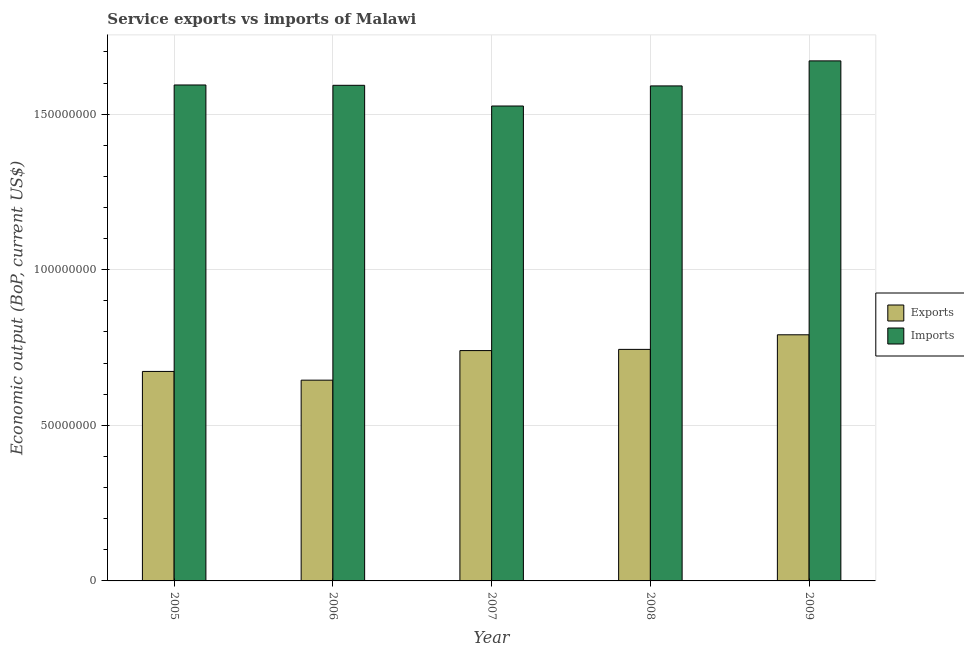How many groups of bars are there?
Your answer should be compact. 5. Are the number of bars per tick equal to the number of legend labels?
Provide a succinct answer. Yes. Are the number of bars on each tick of the X-axis equal?
Offer a terse response. Yes. How many bars are there on the 1st tick from the left?
Make the answer very short. 2. In how many cases, is the number of bars for a given year not equal to the number of legend labels?
Your response must be concise. 0. What is the amount of service imports in 2007?
Keep it short and to the point. 1.53e+08. Across all years, what is the maximum amount of service exports?
Your answer should be compact. 7.91e+07. Across all years, what is the minimum amount of service exports?
Your response must be concise. 6.45e+07. In which year was the amount of service imports minimum?
Offer a terse response. 2007. What is the total amount of service exports in the graph?
Your response must be concise. 3.59e+08. What is the difference between the amount of service exports in 2006 and that in 2009?
Your answer should be very brief. -1.46e+07. What is the difference between the amount of service imports in 2005 and the amount of service exports in 2009?
Ensure brevity in your answer.  -7.74e+06. What is the average amount of service imports per year?
Provide a succinct answer. 1.59e+08. In the year 2006, what is the difference between the amount of service exports and amount of service imports?
Give a very brief answer. 0. In how many years, is the amount of service exports greater than 90000000 US$?
Make the answer very short. 0. What is the ratio of the amount of service exports in 2005 to that in 2009?
Ensure brevity in your answer.  0.85. Is the amount of service imports in 2007 less than that in 2008?
Offer a very short reply. Yes. What is the difference between the highest and the second highest amount of service exports?
Ensure brevity in your answer.  4.69e+06. What is the difference between the highest and the lowest amount of service exports?
Offer a very short reply. 1.46e+07. Is the sum of the amount of service exports in 2005 and 2007 greater than the maximum amount of service imports across all years?
Offer a terse response. Yes. What does the 1st bar from the left in 2006 represents?
Make the answer very short. Exports. What does the 1st bar from the right in 2008 represents?
Give a very brief answer. Imports. How many years are there in the graph?
Provide a short and direct response. 5. Does the graph contain any zero values?
Keep it short and to the point. No. Where does the legend appear in the graph?
Your answer should be very brief. Center right. How many legend labels are there?
Offer a very short reply. 2. How are the legend labels stacked?
Give a very brief answer. Vertical. What is the title of the graph?
Keep it short and to the point. Service exports vs imports of Malawi. Does "From World Bank" appear as one of the legend labels in the graph?
Your answer should be very brief. No. What is the label or title of the Y-axis?
Give a very brief answer. Economic output (BoP, current US$). What is the Economic output (BoP, current US$) of Exports in 2005?
Your response must be concise. 6.73e+07. What is the Economic output (BoP, current US$) in Imports in 2005?
Your response must be concise. 1.59e+08. What is the Economic output (BoP, current US$) of Exports in 2006?
Offer a terse response. 6.45e+07. What is the Economic output (BoP, current US$) of Imports in 2006?
Give a very brief answer. 1.59e+08. What is the Economic output (BoP, current US$) in Exports in 2007?
Give a very brief answer. 7.40e+07. What is the Economic output (BoP, current US$) in Imports in 2007?
Offer a very short reply. 1.53e+08. What is the Economic output (BoP, current US$) in Exports in 2008?
Ensure brevity in your answer.  7.44e+07. What is the Economic output (BoP, current US$) of Imports in 2008?
Your response must be concise. 1.59e+08. What is the Economic output (BoP, current US$) in Exports in 2009?
Offer a very short reply. 7.91e+07. What is the Economic output (BoP, current US$) of Imports in 2009?
Your answer should be compact. 1.67e+08. Across all years, what is the maximum Economic output (BoP, current US$) in Exports?
Make the answer very short. 7.91e+07. Across all years, what is the maximum Economic output (BoP, current US$) in Imports?
Make the answer very short. 1.67e+08. Across all years, what is the minimum Economic output (BoP, current US$) in Exports?
Keep it short and to the point. 6.45e+07. Across all years, what is the minimum Economic output (BoP, current US$) in Imports?
Your response must be concise. 1.53e+08. What is the total Economic output (BoP, current US$) of Exports in the graph?
Your answer should be very brief. 3.59e+08. What is the total Economic output (BoP, current US$) of Imports in the graph?
Offer a terse response. 7.97e+08. What is the difference between the Economic output (BoP, current US$) in Exports in 2005 and that in 2006?
Provide a succinct answer. 2.81e+06. What is the difference between the Economic output (BoP, current US$) of Imports in 2005 and that in 2006?
Your answer should be very brief. 1.06e+05. What is the difference between the Economic output (BoP, current US$) in Exports in 2005 and that in 2007?
Provide a succinct answer. -6.69e+06. What is the difference between the Economic output (BoP, current US$) in Imports in 2005 and that in 2007?
Provide a succinct answer. 6.76e+06. What is the difference between the Economic output (BoP, current US$) of Exports in 2005 and that in 2008?
Your answer should be compact. -7.08e+06. What is the difference between the Economic output (BoP, current US$) in Imports in 2005 and that in 2008?
Offer a terse response. 3.03e+05. What is the difference between the Economic output (BoP, current US$) of Exports in 2005 and that in 2009?
Keep it short and to the point. -1.18e+07. What is the difference between the Economic output (BoP, current US$) of Imports in 2005 and that in 2009?
Offer a very short reply. -7.74e+06. What is the difference between the Economic output (BoP, current US$) of Exports in 2006 and that in 2007?
Provide a succinct answer. -9.50e+06. What is the difference between the Economic output (BoP, current US$) of Imports in 2006 and that in 2007?
Make the answer very short. 6.65e+06. What is the difference between the Economic output (BoP, current US$) of Exports in 2006 and that in 2008?
Ensure brevity in your answer.  -9.89e+06. What is the difference between the Economic output (BoP, current US$) of Imports in 2006 and that in 2008?
Offer a very short reply. 1.97e+05. What is the difference between the Economic output (BoP, current US$) in Exports in 2006 and that in 2009?
Give a very brief answer. -1.46e+07. What is the difference between the Economic output (BoP, current US$) of Imports in 2006 and that in 2009?
Provide a succinct answer. -7.85e+06. What is the difference between the Economic output (BoP, current US$) in Exports in 2007 and that in 2008?
Keep it short and to the point. -3.88e+05. What is the difference between the Economic output (BoP, current US$) in Imports in 2007 and that in 2008?
Your answer should be compact. -6.45e+06. What is the difference between the Economic output (BoP, current US$) in Exports in 2007 and that in 2009?
Provide a short and direct response. -5.08e+06. What is the difference between the Economic output (BoP, current US$) in Imports in 2007 and that in 2009?
Keep it short and to the point. -1.45e+07. What is the difference between the Economic output (BoP, current US$) in Exports in 2008 and that in 2009?
Your response must be concise. -4.69e+06. What is the difference between the Economic output (BoP, current US$) in Imports in 2008 and that in 2009?
Give a very brief answer. -8.05e+06. What is the difference between the Economic output (BoP, current US$) of Exports in 2005 and the Economic output (BoP, current US$) of Imports in 2006?
Offer a terse response. -9.19e+07. What is the difference between the Economic output (BoP, current US$) in Exports in 2005 and the Economic output (BoP, current US$) in Imports in 2007?
Your answer should be very brief. -8.53e+07. What is the difference between the Economic output (BoP, current US$) in Exports in 2005 and the Economic output (BoP, current US$) in Imports in 2008?
Make the answer very short. -9.17e+07. What is the difference between the Economic output (BoP, current US$) of Exports in 2005 and the Economic output (BoP, current US$) of Imports in 2009?
Offer a very short reply. -9.98e+07. What is the difference between the Economic output (BoP, current US$) in Exports in 2006 and the Economic output (BoP, current US$) in Imports in 2007?
Provide a short and direct response. -8.81e+07. What is the difference between the Economic output (BoP, current US$) of Exports in 2006 and the Economic output (BoP, current US$) of Imports in 2008?
Offer a terse response. -9.46e+07. What is the difference between the Economic output (BoP, current US$) in Exports in 2006 and the Economic output (BoP, current US$) in Imports in 2009?
Provide a short and direct response. -1.03e+08. What is the difference between the Economic output (BoP, current US$) in Exports in 2007 and the Economic output (BoP, current US$) in Imports in 2008?
Ensure brevity in your answer.  -8.51e+07. What is the difference between the Economic output (BoP, current US$) of Exports in 2007 and the Economic output (BoP, current US$) of Imports in 2009?
Provide a short and direct response. -9.31e+07. What is the difference between the Economic output (BoP, current US$) in Exports in 2008 and the Economic output (BoP, current US$) in Imports in 2009?
Give a very brief answer. -9.27e+07. What is the average Economic output (BoP, current US$) in Exports per year?
Keep it short and to the point. 7.19e+07. What is the average Economic output (BoP, current US$) in Imports per year?
Your answer should be compact. 1.59e+08. In the year 2005, what is the difference between the Economic output (BoP, current US$) of Exports and Economic output (BoP, current US$) of Imports?
Your response must be concise. -9.20e+07. In the year 2006, what is the difference between the Economic output (BoP, current US$) of Exports and Economic output (BoP, current US$) of Imports?
Offer a terse response. -9.47e+07. In the year 2007, what is the difference between the Economic output (BoP, current US$) in Exports and Economic output (BoP, current US$) in Imports?
Keep it short and to the point. -7.86e+07. In the year 2008, what is the difference between the Economic output (BoP, current US$) in Exports and Economic output (BoP, current US$) in Imports?
Your response must be concise. -8.47e+07. In the year 2009, what is the difference between the Economic output (BoP, current US$) in Exports and Economic output (BoP, current US$) in Imports?
Provide a short and direct response. -8.80e+07. What is the ratio of the Economic output (BoP, current US$) of Exports in 2005 to that in 2006?
Provide a short and direct response. 1.04. What is the ratio of the Economic output (BoP, current US$) in Exports in 2005 to that in 2007?
Your answer should be very brief. 0.91. What is the ratio of the Economic output (BoP, current US$) in Imports in 2005 to that in 2007?
Offer a very short reply. 1.04. What is the ratio of the Economic output (BoP, current US$) in Exports in 2005 to that in 2008?
Ensure brevity in your answer.  0.9. What is the ratio of the Economic output (BoP, current US$) in Exports in 2005 to that in 2009?
Your response must be concise. 0.85. What is the ratio of the Economic output (BoP, current US$) of Imports in 2005 to that in 2009?
Provide a succinct answer. 0.95. What is the ratio of the Economic output (BoP, current US$) in Exports in 2006 to that in 2007?
Give a very brief answer. 0.87. What is the ratio of the Economic output (BoP, current US$) in Imports in 2006 to that in 2007?
Provide a short and direct response. 1.04. What is the ratio of the Economic output (BoP, current US$) in Exports in 2006 to that in 2008?
Offer a very short reply. 0.87. What is the ratio of the Economic output (BoP, current US$) in Imports in 2006 to that in 2008?
Provide a short and direct response. 1. What is the ratio of the Economic output (BoP, current US$) in Exports in 2006 to that in 2009?
Make the answer very short. 0.82. What is the ratio of the Economic output (BoP, current US$) in Imports in 2006 to that in 2009?
Offer a terse response. 0.95. What is the ratio of the Economic output (BoP, current US$) of Exports in 2007 to that in 2008?
Keep it short and to the point. 0.99. What is the ratio of the Economic output (BoP, current US$) in Imports in 2007 to that in 2008?
Give a very brief answer. 0.96. What is the ratio of the Economic output (BoP, current US$) in Exports in 2007 to that in 2009?
Your answer should be compact. 0.94. What is the ratio of the Economic output (BoP, current US$) in Imports in 2007 to that in 2009?
Ensure brevity in your answer.  0.91. What is the ratio of the Economic output (BoP, current US$) of Exports in 2008 to that in 2009?
Provide a succinct answer. 0.94. What is the ratio of the Economic output (BoP, current US$) of Imports in 2008 to that in 2009?
Keep it short and to the point. 0.95. What is the difference between the highest and the second highest Economic output (BoP, current US$) of Exports?
Your response must be concise. 4.69e+06. What is the difference between the highest and the second highest Economic output (BoP, current US$) of Imports?
Provide a succinct answer. 7.74e+06. What is the difference between the highest and the lowest Economic output (BoP, current US$) in Exports?
Provide a succinct answer. 1.46e+07. What is the difference between the highest and the lowest Economic output (BoP, current US$) in Imports?
Your answer should be compact. 1.45e+07. 